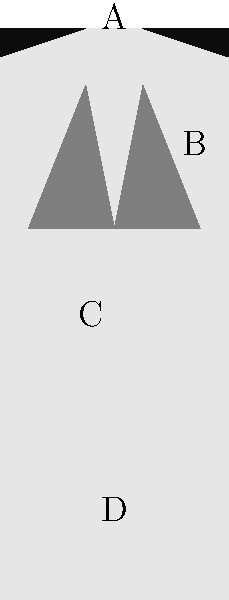Label the parts of this typical 80s power suit. What do the letters A, B, C, and D represent? To identify the parts of a typical 80s power suit, let's break it down step-by-step:

1. Part A: Located at the top of the suit, these are exaggerated shoulder pads. They were a defining feature of 80s power suits, creating a broad-shouldered silhouette that symbolized power and authority.

2. Part B: These are the wide lapels, another characteristic feature of 80s power suits. They were typically broader than in other decades, adding to the overall bold look.

3. Part C: This represents the suit jacket's body. In the 80s, power suits often had a boxy, oversized fit to further emphasize the power look.

4. Part D: This area represents the lower part of the jacket, which would typically extend to the hips or slightly below. 80s power suits often had longer jackets compared to modern suits.

Each of these elements combined to create the iconic 80s power suit look, which was popular among both men and women in professional settings during that era.
Answer: A: Shoulder pads, B: Wide lapels, C: Jacket body, D: Lower jacket 